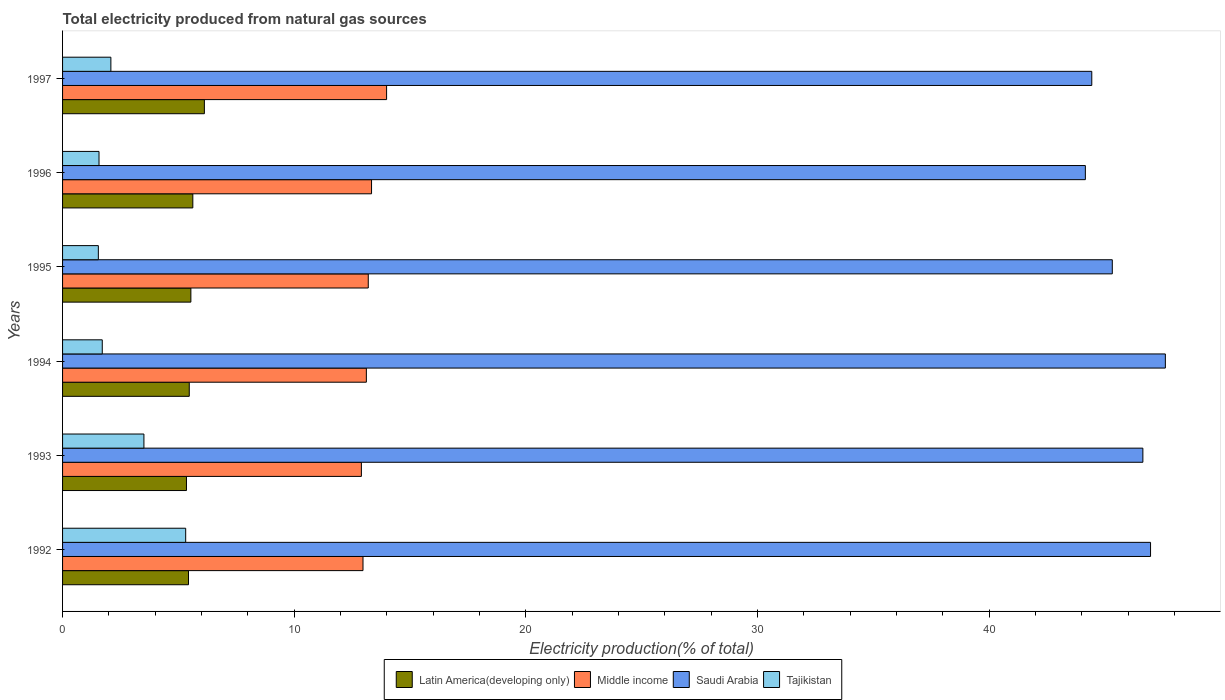How many different coloured bars are there?
Offer a terse response. 4. Are the number of bars per tick equal to the number of legend labels?
Offer a terse response. Yes. How many bars are there on the 3rd tick from the top?
Offer a terse response. 4. How many bars are there on the 1st tick from the bottom?
Offer a very short reply. 4. What is the label of the 6th group of bars from the top?
Provide a succinct answer. 1992. In how many cases, is the number of bars for a given year not equal to the number of legend labels?
Keep it short and to the point. 0. What is the total electricity produced in Middle income in 1993?
Your answer should be very brief. 12.9. Across all years, what is the maximum total electricity produced in Saudi Arabia?
Your answer should be very brief. 47.6. Across all years, what is the minimum total electricity produced in Tajikistan?
Your answer should be very brief. 1.54. In which year was the total electricity produced in Tajikistan maximum?
Provide a succinct answer. 1992. What is the total total electricity produced in Middle income in the graph?
Make the answer very short. 79.5. What is the difference between the total electricity produced in Middle income in 1993 and that in 1997?
Your answer should be very brief. -1.09. What is the difference between the total electricity produced in Middle income in 1996 and the total electricity produced in Saudi Arabia in 1997?
Your answer should be very brief. -31.09. What is the average total electricity produced in Saudi Arabia per year?
Ensure brevity in your answer.  45.85. In the year 1996, what is the difference between the total electricity produced in Tajikistan and total electricity produced in Middle income?
Provide a succinct answer. -11.76. What is the ratio of the total electricity produced in Middle income in 1994 to that in 1996?
Offer a very short reply. 0.98. Is the total electricity produced in Tajikistan in 1992 less than that in 1996?
Give a very brief answer. No. What is the difference between the highest and the second highest total electricity produced in Saudi Arabia?
Your answer should be very brief. 0.64. What is the difference between the highest and the lowest total electricity produced in Saudi Arabia?
Your answer should be compact. 3.45. Is it the case that in every year, the sum of the total electricity produced in Latin America(developing only) and total electricity produced in Tajikistan is greater than the sum of total electricity produced in Saudi Arabia and total electricity produced in Middle income?
Provide a short and direct response. No. What does the 1st bar from the top in 1994 represents?
Make the answer very short. Tajikistan. How many bars are there?
Provide a short and direct response. 24. How many years are there in the graph?
Your response must be concise. 6. Are the values on the major ticks of X-axis written in scientific E-notation?
Ensure brevity in your answer.  No. Does the graph contain any zero values?
Offer a terse response. No. Where does the legend appear in the graph?
Ensure brevity in your answer.  Bottom center. How many legend labels are there?
Make the answer very short. 4. What is the title of the graph?
Ensure brevity in your answer.  Total electricity produced from natural gas sources. What is the label or title of the X-axis?
Provide a succinct answer. Electricity production(% of total). What is the label or title of the Y-axis?
Give a very brief answer. Years. What is the Electricity production(% of total) in Latin America(developing only) in 1992?
Keep it short and to the point. 5.44. What is the Electricity production(% of total) in Middle income in 1992?
Your answer should be very brief. 12.97. What is the Electricity production(% of total) in Saudi Arabia in 1992?
Provide a succinct answer. 46.96. What is the Electricity production(% of total) in Tajikistan in 1992?
Offer a terse response. 5.31. What is the Electricity production(% of total) in Latin America(developing only) in 1993?
Your answer should be very brief. 5.35. What is the Electricity production(% of total) of Middle income in 1993?
Keep it short and to the point. 12.9. What is the Electricity production(% of total) of Saudi Arabia in 1993?
Give a very brief answer. 46.63. What is the Electricity production(% of total) of Tajikistan in 1993?
Your response must be concise. 3.51. What is the Electricity production(% of total) in Latin America(developing only) in 1994?
Your answer should be very brief. 5.47. What is the Electricity production(% of total) in Middle income in 1994?
Offer a terse response. 13.11. What is the Electricity production(% of total) of Saudi Arabia in 1994?
Keep it short and to the point. 47.6. What is the Electricity production(% of total) of Tajikistan in 1994?
Your response must be concise. 1.71. What is the Electricity production(% of total) in Latin America(developing only) in 1995?
Give a very brief answer. 5.54. What is the Electricity production(% of total) of Middle income in 1995?
Your answer should be very brief. 13.2. What is the Electricity production(% of total) of Saudi Arabia in 1995?
Keep it short and to the point. 45.31. What is the Electricity production(% of total) of Tajikistan in 1995?
Offer a very short reply. 1.54. What is the Electricity production(% of total) in Latin America(developing only) in 1996?
Keep it short and to the point. 5.62. What is the Electricity production(% of total) in Middle income in 1996?
Provide a short and direct response. 13.34. What is the Electricity production(% of total) of Saudi Arabia in 1996?
Provide a succinct answer. 44.15. What is the Electricity production(% of total) of Tajikistan in 1996?
Offer a very short reply. 1.57. What is the Electricity production(% of total) in Latin America(developing only) in 1997?
Your response must be concise. 6.12. What is the Electricity production(% of total) in Middle income in 1997?
Offer a terse response. 13.99. What is the Electricity production(% of total) in Saudi Arabia in 1997?
Keep it short and to the point. 44.43. What is the Electricity production(% of total) in Tajikistan in 1997?
Your response must be concise. 2.08. Across all years, what is the maximum Electricity production(% of total) of Latin America(developing only)?
Offer a terse response. 6.12. Across all years, what is the maximum Electricity production(% of total) of Middle income?
Provide a succinct answer. 13.99. Across all years, what is the maximum Electricity production(% of total) of Saudi Arabia?
Your response must be concise. 47.6. Across all years, what is the maximum Electricity production(% of total) in Tajikistan?
Provide a short and direct response. 5.31. Across all years, what is the minimum Electricity production(% of total) of Latin America(developing only)?
Provide a short and direct response. 5.35. Across all years, what is the minimum Electricity production(% of total) of Middle income?
Keep it short and to the point. 12.9. Across all years, what is the minimum Electricity production(% of total) of Saudi Arabia?
Give a very brief answer. 44.15. Across all years, what is the minimum Electricity production(% of total) of Tajikistan?
Make the answer very short. 1.54. What is the total Electricity production(% of total) in Latin America(developing only) in the graph?
Your answer should be very brief. 33.54. What is the total Electricity production(% of total) of Middle income in the graph?
Offer a terse response. 79.5. What is the total Electricity production(% of total) of Saudi Arabia in the graph?
Provide a short and direct response. 275.09. What is the total Electricity production(% of total) in Tajikistan in the graph?
Your response must be concise. 15.74. What is the difference between the Electricity production(% of total) of Latin America(developing only) in 1992 and that in 1993?
Ensure brevity in your answer.  0.09. What is the difference between the Electricity production(% of total) in Middle income in 1992 and that in 1993?
Make the answer very short. 0.07. What is the difference between the Electricity production(% of total) of Saudi Arabia in 1992 and that in 1993?
Your answer should be compact. 0.33. What is the difference between the Electricity production(% of total) in Tajikistan in 1992 and that in 1993?
Keep it short and to the point. 1.8. What is the difference between the Electricity production(% of total) in Latin America(developing only) in 1992 and that in 1994?
Provide a short and direct response. -0.03. What is the difference between the Electricity production(% of total) of Middle income in 1992 and that in 1994?
Offer a terse response. -0.14. What is the difference between the Electricity production(% of total) in Saudi Arabia in 1992 and that in 1994?
Ensure brevity in your answer.  -0.64. What is the difference between the Electricity production(% of total) of Tajikistan in 1992 and that in 1994?
Provide a short and direct response. 3.6. What is the difference between the Electricity production(% of total) of Latin America(developing only) in 1992 and that in 1995?
Offer a terse response. -0.1. What is the difference between the Electricity production(% of total) in Middle income in 1992 and that in 1995?
Your answer should be very brief. -0.23. What is the difference between the Electricity production(% of total) in Saudi Arabia in 1992 and that in 1995?
Provide a short and direct response. 1.65. What is the difference between the Electricity production(% of total) in Tajikistan in 1992 and that in 1995?
Make the answer very short. 3.77. What is the difference between the Electricity production(% of total) of Latin America(developing only) in 1992 and that in 1996?
Offer a very short reply. -0.19. What is the difference between the Electricity production(% of total) in Middle income in 1992 and that in 1996?
Provide a short and direct response. -0.37. What is the difference between the Electricity production(% of total) of Saudi Arabia in 1992 and that in 1996?
Keep it short and to the point. 2.81. What is the difference between the Electricity production(% of total) of Tajikistan in 1992 and that in 1996?
Your answer should be very brief. 3.74. What is the difference between the Electricity production(% of total) of Latin America(developing only) in 1992 and that in 1997?
Your answer should be very brief. -0.69. What is the difference between the Electricity production(% of total) in Middle income in 1992 and that in 1997?
Provide a succinct answer. -1.02. What is the difference between the Electricity production(% of total) in Saudi Arabia in 1992 and that in 1997?
Give a very brief answer. 2.54. What is the difference between the Electricity production(% of total) in Tajikistan in 1992 and that in 1997?
Ensure brevity in your answer.  3.23. What is the difference between the Electricity production(% of total) of Latin America(developing only) in 1993 and that in 1994?
Keep it short and to the point. -0.12. What is the difference between the Electricity production(% of total) in Middle income in 1993 and that in 1994?
Keep it short and to the point. -0.21. What is the difference between the Electricity production(% of total) of Saudi Arabia in 1993 and that in 1994?
Provide a succinct answer. -0.97. What is the difference between the Electricity production(% of total) of Tajikistan in 1993 and that in 1994?
Make the answer very short. 1.8. What is the difference between the Electricity production(% of total) of Latin America(developing only) in 1993 and that in 1995?
Offer a very short reply. -0.19. What is the difference between the Electricity production(% of total) of Middle income in 1993 and that in 1995?
Your response must be concise. -0.3. What is the difference between the Electricity production(% of total) of Saudi Arabia in 1993 and that in 1995?
Keep it short and to the point. 1.32. What is the difference between the Electricity production(% of total) of Tajikistan in 1993 and that in 1995?
Provide a succinct answer. 1.97. What is the difference between the Electricity production(% of total) in Latin America(developing only) in 1993 and that in 1996?
Give a very brief answer. -0.27. What is the difference between the Electricity production(% of total) of Middle income in 1993 and that in 1996?
Make the answer very short. -0.44. What is the difference between the Electricity production(% of total) in Saudi Arabia in 1993 and that in 1996?
Make the answer very short. 2.48. What is the difference between the Electricity production(% of total) of Tajikistan in 1993 and that in 1996?
Your answer should be very brief. 1.94. What is the difference between the Electricity production(% of total) in Latin America(developing only) in 1993 and that in 1997?
Your answer should be very brief. -0.77. What is the difference between the Electricity production(% of total) of Middle income in 1993 and that in 1997?
Offer a terse response. -1.09. What is the difference between the Electricity production(% of total) in Saudi Arabia in 1993 and that in 1997?
Your answer should be very brief. 2.21. What is the difference between the Electricity production(% of total) in Tajikistan in 1993 and that in 1997?
Offer a terse response. 1.43. What is the difference between the Electricity production(% of total) of Latin America(developing only) in 1994 and that in 1995?
Provide a succinct answer. -0.07. What is the difference between the Electricity production(% of total) of Middle income in 1994 and that in 1995?
Your answer should be compact. -0.08. What is the difference between the Electricity production(% of total) of Saudi Arabia in 1994 and that in 1995?
Offer a very short reply. 2.29. What is the difference between the Electricity production(% of total) in Tajikistan in 1994 and that in 1995?
Keep it short and to the point. 0.17. What is the difference between the Electricity production(% of total) in Latin America(developing only) in 1994 and that in 1996?
Offer a very short reply. -0.15. What is the difference between the Electricity production(% of total) of Middle income in 1994 and that in 1996?
Make the answer very short. -0.22. What is the difference between the Electricity production(% of total) of Saudi Arabia in 1994 and that in 1996?
Provide a short and direct response. 3.45. What is the difference between the Electricity production(% of total) of Tajikistan in 1994 and that in 1996?
Provide a succinct answer. 0.14. What is the difference between the Electricity production(% of total) of Latin America(developing only) in 1994 and that in 1997?
Provide a short and direct response. -0.65. What is the difference between the Electricity production(% of total) of Middle income in 1994 and that in 1997?
Ensure brevity in your answer.  -0.87. What is the difference between the Electricity production(% of total) of Saudi Arabia in 1994 and that in 1997?
Your answer should be compact. 3.18. What is the difference between the Electricity production(% of total) in Tajikistan in 1994 and that in 1997?
Provide a succinct answer. -0.37. What is the difference between the Electricity production(% of total) in Latin America(developing only) in 1995 and that in 1996?
Keep it short and to the point. -0.08. What is the difference between the Electricity production(% of total) in Middle income in 1995 and that in 1996?
Provide a short and direct response. -0.14. What is the difference between the Electricity production(% of total) in Saudi Arabia in 1995 and that in 1996?
Ensure brevity in your answer.  1.16. What is the difference between the Electricity production(% of total) of Tajikistan in 1995 and that in 1996?
Your answer should be compact. -0.03. What is the difference between the Electricity production(% of total) in Latin America(developing only) in 1995 and that in 1997?
Give a very brief answer. -0.58. What is the difference between the Electricity production(% of total) in Middle income in 1995 and that in 1997?
Give a very brief answer. -0.79. What is the difference between the Electricity production(% of total) in Saudi Arabia in 1995 and that in 1997?
Give a very brief answer. 0.89. What is the difference between the Electricity production(% of total) of Tajikistan in 1995 and that in 1997?
Offer a terse response. -0.54. What is the difference between the Electricity production(% of total) in Latin America(developing only) in 1996 and that in 1997?
Your answer should be compact. -0.5. What is the difference between the Electricity production(% of total) of Middle income in 1996 and that in 1997?
Your answer should be compact. -0.65. What is the difference between the Electricity production(% of total) of Saudi Arabia in 1996 and that in 1997?
Keep it short and to the point. -0.28. What is the difference between the Electricity production(% of total) of Tajikistan in 1996 and that in 1997?
Offer a terse response. -0.51. What is the difference between the Electricity production(% of total) in Latin America(developing only) in 1992 and the Electricity production(% of total) in Middle income in 1993?
Offer a very short reply. -7.46. What is the difference between the Electricity production(% of total) in Latin America(developing only) in 1992 and the Electricity production(% of total) in Saudi Arabia in 1993?
Offer a very short reply. -41.2. What is the difference between the Electricity production(% of total) in Latin America(developing only) in 1992 and the Electricity production(% of total) in Tajikistan in 1993?
Your answer should be very brief. 1.92. What is the difference between the Electricity production(% of total) in Middle income in 1992 and the Electricity production(% of total) in Saudi Arabia in 1993?
Your response must be concise. -33.66. What is the difference between the Electricity production(% of total) of Middle income in 1992 and the Electricity production(% of total) of Tajikistan in 1993?
Make the answer very short. 9.46. What is the difference between the Electricity production(% of total) of Saudi Arabia in 1992 and the Electricity production(% of total) of Tajikistan in 1993?
Your answer should be very brief. 43.45. What is the difference between the Electricity production(% of total) in Latin America(developing only) in 1992 and the Electricity production(% of total) in Middle income in 1994?
Offer a terse response. -7.68. What is the difference between the Electricity production(% of total) of Latin America(developing only) in 1992 and the Electricity production(% of total) of Saudi Arabia in 1994?
Ensure brevity in your answer.  -42.17. What is the difference between the Electricity production(% of total) in Latin America(developing only) in 1992 and the Electricity production(% of total) in Tajikistan in 1994?
Your response must be concise. 3.72. What is the difference between the Electricity production(% of total) of Middle income in 1992 and the Electricity production(% of total) of Saudi Arabia in 1994?
Offer a very short reply. -34.63. What is the difference between the Electricity production(% of total) in Middle income in 1992 and the Electricity production(% of total) in Tajikistan in 1994?
Provide a short and direct response. 11.25. What is the difference between the Electricity production(% of total) in Saudi Arabia in 1992 and the Electricity production(% of total) in Tajikistan in 1994?
Keep it short and to the point. 45.25. What is the difference between the Electricity production(% of total) in Latin America(developing only) in 1992 and the Electricity production(% of total) in Middle income in 1995?
Ensure brevity in your answer.  -7.76. What is the difference between the Electricity production(% of total) in Latin America(developing only) in 1992 and the Electricity production(% of total) in Saudi Arabia in 1995?
Make the answer very short. -39.88. What is the difference between the Electricity production(% of total) in Latin America(developing only) in 1992 and the Electricity production(% of total) in Tajikistan in 1995?
Give a very brief answer. 3.89. What is the difference between the Electricity production(% of total) of Middle income in 1992 and the Electricity production(% of total) of Saudi Arabia in 1995?
Give a very brief answer. -32.34. What is the difference between the Electricity production(% of total) of Middle income in 1992 and the Electricity production(% of total) of Tajikistan in 1995?
Your answer should be very brief. 11.42. What is the difference between the Electricity production(% of total) of Saudi Arabia in 1992 and the Electricity production(% of total) of Tajikistan in 1995?
Provide a succinct answer. 45.42. What is the difference between the Electricity production(% of total) in Latin America(developing only) in 1992 and the Electricity production(% of total) in Middle income in 1996?
Provide a short and direct response. -7.9. What is the difference between the Electricity production(% of total) of Latin America(developing only) in 1992 and the Electricity production(% of total) of Saudi Arabia in 1996?
Provide a short and direct response. -38.71. What is the difference between the Electricity production(% of total) of Latin America(developing only) in 1992 and the Electricity production(% of total) of Tajikistan in 1996?
Offer a terse response. 3.86. What is the difference between the Electricity production(% of total) in Middle income in 1992 and the Electricity production(% of total) in Saudi Arabia in 1996?
Your answer should be compact. -31.18. What is the difference between the Electricity production(% of total) of Middle income in 1992 and the Electricity production(% of total) of Tajikistan in 1996?
Provide a succinct answer. 11.39. What is the difference between the Electricity production(% of total) in Saudi Arabia in 1992 and the Electricity production(% of total) in Tajikistan in 1996?
Provide a succinct answer. 45.39. What is the difference between the Electricity production(% of total) of Latin America(developing only) in 1992 and the Electricity production(% of total) of Middle income in 1997?
Keep it short and to the point. -8.55. What is the difference between the Electricity production(% of total) of Latin America(developing only) in 1992 and the Electricity production(% of total) of Saudi Arabia in 1997?
Provide a succinct answer. -38.99. What is the difference between the Electricity production(% of total) in Latin America(developing only) in 1992 and the Electricity production(% of total) in Tajikistan in 1997?
Your response must be concise. 3.35. What is the difference between the Electricity production(% of total) of Middle income in 1992 and the Electricity production(% of total) of Saudi Arabia in 1997?
Offer a very short reply. -31.46. What is the difference between the Electricity production(% of total) in Middle income in 1992 and the Electricity production(% of total) in Tajikistan in 1997?
Offer a terse response. 10.88. What is the difference between the Electricity production(% of total) of Saudi Arabia in 1992 and the Electricity production(% of total) of Tajikistan in 1997?
Provide a succinct answer. 44.88. What is the difference between the Electricity production(% of total) of Latin America(developing only) in 1993 and the Electricity production(% of total) of Middle income in 1994?
Ensure brevity in your answer.  -7.77. What is the difference between the Electricity production(% of total) of Latin America(developing only) in 1993 and the Electricity production(% of total) of Saudi Arabia in 1994?
Offer a terse response. -42.25. What is the difference between the Electricity production(% of total) of Latin America(developing only) in 1993 and the Electricity production(% of total) of Tajikistan in 1994?
Offer a terse response. 3.63. What is the difference between the Electricity production(% of total) in Middle income in 1993 and the Electricity production(% of total) in Saudi Arabia in 1994?
Your response must be concise. -34.7. What is the difference between the Electricity production(% of total) in Middle income in 1993 and the Electricity production(% of total) in Tajikistan in 1994?
Keep it short and to the point. 11.19. What is the difference between the Electricity production(% of total) of Saudi Arabia in 1993 and the Electricity production(% of total) of Tajikistan in 1994?
Your answer should be very brief. 44.92. What is the difference between the Electricity production(% of total) in Latin America(developing only) in 1993 and the Electricity production(% of total) in Middle income in 1995?
Offer a terse response. -7.85. What is the difference between the Electricity production(% of total) of Latin America(developing only) in 1993 and the Electricity production(% of total) of Saudi Arabia in 1995?
Your answer should be compact. -39.96. What is the difference between the Electricity production(% of total) in Latin America(developing only) in 1993 and the Electricity production(% of total) in Tajikistan in 1995?
Offer a terse response. 3.8. What is the difference between the Electricity production(% of total) in Middle income in 1993 and the Electricity production(% of total) in Saudi Arabia in 1995?
Keep it short and to the point. -32.41. What is the difference between the Electricity production(% of total) in Middle income in 1993 and the Electricity production(% of total) in Tajikistan in 1995?
Your response must be concise. 11.35. What is the difference between the Electricity production(% of total) in Saudi Arabia in 1993 and the Electricity production(% of total) in Tajikistan in 1995?
Keep it short and to the point. 45.09. What is the difference between the Electricity production(% of total) in Latin America(developing only) in 1993 and the Electricity production(% of total) in Middle income in 1996?
Offer a very short reply. -7.99. What is the difference between the Electricity production(% of total) of Latin America(developing only) in 1993 and the Electricity production(% of total) of Saudi Arabia in 1996?
Your answer should be compact. -38.8. What is the difference between the Electricity production(% of total) of Latin America(developing only) in 1993 and the Electricity production(% of total) of Tajikistan in 1996?
Offer a very short reply. 3.77. What is the difference between the Electricity production(% of total) in Middle income in 1993 and the Electricity production(% of total) in Saudi Arabia in 1996?
Provide a short and direct response. -31.25. What is the difference between the Electricity production(% of total) in Middle income in 1993 and the Electricity production(% of total) in Tajikistan in 1996?
Give a very brief answer. 11.33. What is the difference between the Electricity production(% of total) in Saudi Arabia in 1993 and the Electricity production(% of total) in Tajikistan in 1996?
Your response must be concise. 45.06. What is the difference between the Electricity production(% of total) in Latin America(developing only) in 1993 and the Electricity production(% of total) in Middle income in 1997?
Make the answer very short. -8.64. What is the difference between the Electricity production(% of total) of Latin America(developing only) in 1993 and the Electricity production(% of total) of Saudi Arabia in 1997?
Ensure brevity in your answer.  -39.08. What is the difference between the Electricity production(% of total) in Latin America(developing only) in 1993 and the Electricity production(% of total) in Tajikistan in 1997?
Your answer should be very brief. 3.26. What is the difference between the Electricity production(% of total) in Middle income in 1993 and the Electricity production(% of total) in Saudi Arabia in 1997?
Offer a very short reply. -31.53. What is the difference between the Electricity production(% of total) of Middle income in 1993 and the Electricity production(% of total) of Tajikistan in 1997?
Your response must be concise. 10.81. What is the difference between the Electricity production(% of total) in Saudi Arabia in 1993 and the Electricity production(% of total) in Tajikistan in 1997?
Ensure brevity in your answer.  44.55. What is the difference between the Electricity production(% of total) in Latin America(developing only) in 1994 and the Electricity production(% of total) in Middle income in 1995?
Your answer should be compact. -7.73. What is the difference between the Electricity production(% of total) in Latin America(developing only) in 1994 and the Electricity production(% of total) in Saudi Arabia in 1995?
Offer a very short reply. -39.84. What is the difference between the Electricity production(% of total) in Latin America(developing only) in 1994 and the Electricity production(% of total) in Tajikistan in 1995?
Offer a very short reply. 3.92. What is the difference between the Electricity production(% of total) of Middle income in 1994 and the Electricity production(% of total) of Saudi Arabia in 1995?
Offer a terse response. -32.2. What is the difference between the Electricity production(% of total) of Middle income in 1994 and the Electricity production(% of total) of Tajikistan in 1995?
Give a very brief answer. 11.57. What is the difference between the Electricity production(% of total) in Saudi Arabia in 1994 and the Electricity production(% of total) in Tajikistan in 1995?
Offer a terse response. 46.06. What is the difference between the Electricity production(% of total) of Latin America(developing only) in 1994 and the Electricity production(% of total) of Middle income in 1996?
Offer a terse response. -7.87. What is the difference between the Electricity production(% of total) of Latin America(developing only) in 1994 and the Electricity production(% of total) of Saudi Arabia in 1996?
Your response must be concise. -38.68. What is the difference between the Electricity production(% of total) in Latin America(developing only) in 1994 and the Electricity production(% of total) in Tajikistan in 1996?
Your answer should be very brief. 3.9. What is the difference between the Electricity production(% of total) in Middle income in 1994 and the Electricity production(% of total) in Saudi Arabia in 1996?
Your answer should be compact. -31.04. What is the difference between the Electricity production(% of total) in Middle income in 1994 and the Electricity production(% of total) in Tajikistan in 1996?
Keep it short and to the point. 11.54. What is the difference between the Electricity production(% of total) of Saudi Arabia in 1994 and the Electricity production(% of total) of Tajikistan in 1996?
Your answer should be very brief. 46.03. What is the difference between the Electricity production(% of total) in Latin America(developing only) in 1994 and the Electricity production(% of total) in Middle income in 1997?
Keep it short and to the point. -8.52. What is the difference between the Electricity production(% of total) of Latin America(developing only) in 1994 and the Electricity production(% of total) of Saudi Arabia in 1997?
Make the answer very short. -38.96. What is the difference between the Electricity production(% of total) in Latin America(developing only) in 1994 and the Electricity production(% of total) in Tajikistan in 1997?
Make the answer very short. 3.38. What is the difference between the Electricity production(% of total) in Middle income in 1994 and the Electricity production(% of total) in Saudi Arabia in 1997?
Give a very brief answer. -31.31. What is the difference between the Electricity production(% of total) of Middle income in 1994 and the Electricity production(% of total) of Tajikistan in 1997?
Give a very brief answer. 11.03. What is the difference between the Electricity production(% of total) of Saudi Arabia in 1994 and the Electricity production(% of total) of Tajikistan in 1997?
Make the answer very short. 45.52. What is the difference between the Electricity production(% of total) in Latin America(developing only) in 1995 and the Electricity production(% of total) in Middle income in 1996?
Offer a terse response. -7.8. What is the difference between the Electricity production(% of total) in Latin America(developing only) in 1995 and the Electricity production(% of total) in Saudi Arabia in 1996?
Your answer should be compact. -38.61. What is the difference between the Electricity production(% of total) in Latin America(developing only) in 1995 and the Electricity production(% of total) in Tajikistan in 1996?
Offer a terse response. 3.96. What is the difference between the Electricity production(% of total) in Middle income in 1995 and the Electricity production(% of total) in Saudi Arabia in 1996?
Ensure brevity in your answer.  -30.95. What is the difference between the Electricity production(% of total) in Middle income in 1995 and the Electricity production(% of total) in Tajikistan in 1996?
Provide a succinct answer. 11.62. What is the difference between the Electricity production(% of total) in Saudi Arabia in 1995 and the Electricity production(% of total) in Tajikistan in 1996?
Give a very brief answer. 43.74. What is the difference between the Electricity production(% of total) in Latin America(developing only) in 1995 and the Electricity production(% of total) in Middle income in 1997?
Your answer should be very brief. -8.45. What is the difference between the Electricity production(% of total) in Latin America(developing only) in 1995 and the Electricity production(% of total) in Saudi Arabia in 1997?
Your response must be concise. -38.89. What is the difference between the Electricity production(% of total) of Latin America(developing only) in 1995 and the Electricity production(% of total) of Tajikistan in 1997?
Make the answer very short. 3.45. What is the difference between the Electricity production(% of total) of Middle income in 1995 and the Electricity production(% of total) of Saudi Arabia in 1997?
Your answer should be compact. -31.23. What is the difference between the Electricity production(% of total) of Middle income in 1995 and the Electricity production(% of total) of Tajikistan in 1997?
Give a very brief answer. 11.11. What is the difference between the Electricity production(% of total) in Saudi Arabia in 1995 and the Electricity production(% of total) in Tajikistan in 1997?
Offer a terse response. 43.23. What is the difference between the Electricity production(% of total) of Latin America(developing only) in 1996 and the Electricity production(% of total) of Middle income in 1997?
Provide a short and direct response. -8.36. What is the difference between the Electricity production(% of total) in Latin America(developing only) in 1996 and the Electricity production(% of total) in Saudi Arabia in 1997?
Your response must be concise. -38.8. What is the difference between the Electricity production(% of total) in Latin America(developing only) in 1996 and the Electricity production(% of total) in Tajikistan in 1997?
Make the answer very short. 3.54. What is the difference between the Electricity production(% of total) in Middle income in 1996 and the Electricity production(% of total) in Saudi Arabia in 1997?
Make the answer very short. -31.09. What is the difference between the Electricity production(% of total) of Middle income in 1996 and the Electricity production(% of total) of Tajikistan in 1997?
Give a very brief answer. 11.25. What is the difference between the Electricity production(% of total) in Saudi Arabia in 1996 and the Electricity production(% of total) in Tajikistan in 1997?
Your answer should be compact. 42.06. What is the average Electricity production(% of total) in Latin America(developing only) per year?
Provide a short and direct response. 5.59. What is the average Electricity production(% of total) of Middle income per year?
Your answer should be compact. 13.25. What is the average Electricity production(% of total) in Saudi Arabia per year?
Give a very brief answer. 45.85. What is the average Electricity production(% of total) of Tajikistan per year?
Your answer should be compact. 2.62. In the year 1992, what is the difference between the Electricity production(% of total) of Latin America(developing only) and Electricity production(% of total) of Middle income?
Offer a terse response. -7.53. In the year 1992, what is the difference between the Electricity production(% of total) of Latin America(developing only) and Electricity production(% of total) of Saudi Arabia?
Ensure brevity in your answer.  -41.53. In the year 1992, what is the difference between the Electricity production(% of total) in Latin America(developing only) and Electricity production(% of total) in Tajikistan?
Make the answer very short. 0.12. In the year 1992, what is the difference between the Electricity production(% of total) in Middle income and Electricity production(% of total) in Saudi Arabia?
Keep it short and to the point. -33.99. In the year 1992, what is the difference between the Electricity production(% of total) in Middle income and Electricity production(% of total) in Tajikistan?
Your answer should be very brief. 7.65. In the year 1992, what is the difference between the Electricity production(% of total) of Saudi Arabia and Electricity production(% of total) of Tajikistan?
Provide a succinct answer. 41.65. In the year 1993, what is the difference between the Electricity production(% of total) of Latin America(developing only) and Electricity production(% of total) of Middle income?
Keep it short and to the point. -7.55. In the year 1993, what is the difference between the Electricity production(% of total) of Latin America(developing only) and Electricity production(% of total) of Saudi Arabia?
Offer a very short reply. -41.28. In the year 1993, what is the difference between the Electricity production(% of total) in Latin America(developing only) and Electricity production(% of total) in Tajikistan?
Provide a short and direct response. 1.84. In the year 1993, what is the difference between the Electricity production(% of total) in Middle income and Electricity production(% of total) in Saudi Arabia?
Keep it short and to the point. -33.73. In the year 1993, what is the difference between the Electricity production(% of total) of Middle income and Electricity production(% of total) of Tajikistan?
Your answer should be compact. 9.39. In the year 1993, what is the difference between the Electricity production(% of total) of Saudi Arabia and Electricity production(% of total) of Tajikistan?
Your answer should be very brief. 43.12. In the year 1994, what is the difference between the Electricity production(% of total) in Latin America(developing only) and Electricity production(% of total) in Middle income?
Provide a succinct answer. -7.64. In the year 1994, what is the difference between the Electricity production(% of total) of Latin America(developing only) and Electricity production(% of total) of Saudi Arabia?
Provide a succinct answer. -42.13. In the year 1994, what is the difference between the Electricity production(% of total) in Latin America(developing only) and Electricity production(% of total) in Tajikistan?
Make the answer very short. 3.76. In the year 1994, what is the difference between the Electricity production(% of total) in Middle income and Electricity production(% of total) in Saudi Arabia?
Your answer should be compact. -34.49. In the year 1994, what is the difference between the Electricity production(% of total) of Middle income and Electricity production(% of total) of Tajikistan?
Ensure brevity in your answer.  11.4. In the year 1994, what is the difference between the Electricity production(% of total) of Saudi Arabia and Electricity production(% of total) of Tajikistan?
Make the answer very short. 45.89. In the year 1995, what is the difference between the Electricity production(% of total) of Latin America(developing only) and Electricity production(% of total) of Middle income?
Your response must be concise. -7.66. In the year 1995, what is the difference between the Electricity production(% of total) in Latin America(developing only) and Electricity production(% of total) in Saudi Arabia?
Ensure brevity in your answer.  -39.77. In the year 1995, what is the difference between the Electricity production(% of total) in Latin America(developing only) and Electricity production(% of total) in Tajikistan?
Ensure brevity in your answer.  3.99. In the year 1995, what is the difference between the Electricity production(% of total) in Middle income and Electricity production(% of total) in Saudi Arabia?
Provide a succinct answer. -32.12. In the year 1995, what is the difference between the Electricity production(% of total) of Middle income and Electricity production(% of total) of Tajikistan?
Keep it short and to the point. 11.65. In the year 1995, what is the difference between the Electricity production(% of total) of Saudi Arabia and Electricity production(% of total) of Tajikistan?
Your answer should be very brief. 43.77. In the year 1996, what is the difference between the Electricity production(% of total) of Latin America(developing only) and Electricity production(% of total) of Middle income?
Provide a short and direct response. -7.71. In the year 1996, what is the difference between the Electricity production(% of total) in Latin America(developing only) and Electricity production(% of total) in Saudi Arabia?
Ensure brevity in your answer.  -38.53. In the year 1996, what is the difference between the Electricity production(% of total) of Latin America(developing only) and Electricity production(% of total) of Tajikistan?
Give a very brief answer. 4.05. In the year 1996, what is the difference between the Electricity production(% of total) of Middle income and Electricity production(% of total) of Saudi Arabia?
Give a very brief answer. -30.81. In the year 1996, what is the difference between the Electricity production(% of total) in Middle income and Electricity production(% of total) in Tajikistan?
Your response must be concise. 11.76. In the year 1996, what is the difference between the Electricity production(% of total) in Saudi Arabia and Electricity production(% of total) in Tajikistan?
Make the answer very short. 42.58. In the year 1997, what is the difference between the Electricity production(% of total) in Latin America(developing only) and Electricity production(% of total) in Middle income?
Offer a very short reply. -7.87. In the year 1997, what is the difference between the Electricity production(% of total) of Latin America(developing only) and Electricity production(% of total) of Saudi Arabia?
Keep it short and to the point. -38.31. In the year 1997, what is the difference between the Electricity production(% of total) in Latin America(developing only) and Electricity production(% of total) in Tajikistan?
Your answer should be compact. 4.04. In the year 1997, what is the difference between the Electricity production(% of total) of Middle income and Electricity production(% of total) of Saudi Arabia?
Offer a very short reply. -30.44. In the year 1997, what is the difference between the Electricity production(% of total) in Middle income and Electricity production(% of total) in Tajikistan?
Provide a succinct answer. 11.9. In the year 1997, what is the difference between the Electricity production(% of total) in Saudi Arabia and Electricity production(% of total) in Tajikistan?
Give a very brief answer. 42.34. What is the ratio of the Electricity production(% of total) of Latin America(developing only) in 1992 to that in 1993?
Provide a succinct answer. 1.02. What is the ratio of the Electricity production(% of total) in Middle income in 1992 to that in 1993?
Ensure brevity in your answer.  1.01. What is the ratio of the Electricity production(% of total) of Saudi Arabia in 1992 to that in 1993?
Your answer should be very brief. 1.01. What is the ratio of the Electricity production(% of total) of Tajikistan in 1992 to that in 1993?
Provide a short and direct response. 1.51. What is the ratio of the Electricity production(% of total) in Latin America(developing only) in 1992 to that in 1994?
Make the answer very short. 0.99. What is the ratio of the Electricity production(% of total) of Saudi Arabia in 1992 to that in 1994?
Keep it short and to the point. 0.99. What is the ratio of the Electricity production(% of total) in Tajikistan in 1992 to that in 1994?
Ensure brevity in your answer.  3.1. What is the ratio of the Electricity production(% of total) of Latin America(developing only) in 1992 to that in 1995?
Make the answer very short. 0.98. What is the ratio of the Electricity production(% of total) of Middle income in 1992 to that in 1995?
Keep it short and to the point. 0.98. What is the ratio of the Electricity production(% of total) in Saudi Arabia in 1992 to that in 1995?
Ensure brevity in your answer.  1.04. What is the ratio of the Electricity production(% of total) of Tajikistan in 1992 to that in 1995?
Keep it short and to the point. 3.44. What is the ratio of the Electricity production(% of total) in Latin America(developing only) in 1992 to that in 1996?
Give a very brief answer. 0.97. What is the ratio of the Electricity production(% of total) of Middle income in 1992 to that in 1996?
Offer a terse response. 0.97. What is the ratio of the Electricity production(% of total) of Saudi Arabia in 1992 to that in 1996?
Offer a terse response. 1.06. What is the ratio of the Electricity production(% of total) of Tajikistan in 1992 to that in 1996?
Give a very brief answer. 3.38. What is the ratio of the Electricity production(% of total) of Latin America(developing only) in 1992 to that in 1997?
Give a very brief answer. 0.89. What is the ratio of the Electricity production(% of total) of Middle income in 1992 to that in 1997?
Give a very brief answer. 0.93. What is the ratio of the Electricity production(% of total) in Saudi Arabia in 1992 to that in 1997?
Offer a terse response. 1.06. What is the ratio of the Electricity production(% of total) of Tajikistan in 1992 to that in 1997?
Provide a succinct answer. 2.55. What is the ratio of the Electricity production(% of total) in Latin America(developing only) in 1993 to that in 1994?
Keep it short and to the point. 0.98. What is the ratio of the Electricity production(% of total) in Middle income in 1993 to that in 1994?
Ensure brevity in your answer.  0.98. What is the ratio of the Electricity production(% of total) of Saudi Arabia in 1993 to that in 1994?
Provide a succinct answer. 0.98. What is the ratio of the Electricity production(% of total) of Tajikistan in 1993 to that in 1994?
Your answer should be very brief. 2.05. What is the ratio of the Electricity production(% of total) in Latin America(developing only) in 1993 to that in 1995?
Ensure brevity in your answer.  0.97. What is the ratio of the Electricity production(% of total) of Middle income in 1993 to that in 1995?
Provide a succinct answer. 0.98. What is the ratio of the Electricity production(% of total) of Saudi Arabia in 1993 to that in 1995?
Provide a succinct answer. 1.03. What is the ratio of the Electricity production(% of total) of Tajikistan in 1993 to that in 1995?
Offer a very short reply. 2.27. What is the ratio of the Electricity production(% of total) in Latin America(developing only) in 1993 to that in 1996?
Keep it short and to the point. 0.95. What is the ratio of the Electricity production(% of total) of Middle income in 1993 to that in 1996?
Your answer should be very brief. 0.97. What is the ratio of the Electricity production(% of total) in Saudi Arabia in 1993 to that in 1996?
Provide a short and direct response. 1.06. What is the ratio of the Electricity production(% of total) of Tajikistan in 1993 to that in 1996?
Ensure brevity in your answer.  2.23. What is the ratio of the Electricity production(% of total) of Latin America(developing only) in 1993 to that in 1997?
Make the answer very short. 0.87. What is the ratio of the Electricity production(% of total) in Middle income in 1993 to that in 1997?
Ensure brevity in your answer.  0.92. What is the ratio of the Electricity production(% of total) in Saudi Arabia in 1993 to that in 1997?
Provide a short and direct response. 1.05. What is the ratio of the Electricity production(% of total) of Tajikistan in 1993 to that in 1997?
Offer a terse response. 1.68. What is the ratio of the Electricity production(% of total) of Latin America(developing only) in 1994 to that in 1995?
Your answer should be compact. 0.99. What is the ratio of the Electricity production(% of total) of Middle income in 1994 to that in 1995?
Keep it short and to the point. 0.99. What is the ratio of the Electricity production(% of total) in Saudi Arabia in 1994 to that in 1995?
Keep it short and to the point. 1.05. What is the ratio of the Electricity production(% of total) of Tajikistan in 1994 to that in 1995?
Your answer should be compact. 1.11. What is the ratio of the Electricity production(% of total) in Latin America(developing only) in 1994 to that in 1996?
Keep it short and to the point. 0.97. What is the ratio of the Electricity production(% of total) in Middle income in 1994 to that in 1996?
Offer a terse response. 0.98. What is the ratio of the Electricity production(% of total) in Saudi Arabia in 1994 to that in 1996?
Ensure brevity in your answer.  1.08. What is the ratio of the Electricity production(% of total) in Tajikistan in 1994 to that in 1996?
Provide a short and direct response. 1.09. What is the ratio of the Electricity production(% of total) of Latin America(developing only) in 1994 to that in 1997?
Keep it short and to the point. 0.89. What is the ratio of the Electricity production(% of total) of Middle income in 1994 to that in 1997?
Provide a succinct answer. 0.94. What is the ratio of the Electricity production(% of total) in Saudi Arabia in 1994 to that in 1997?
Give a very brief answer. 1.07. What is the ratio of the Electricity production(% of total) of Tajikistan in 1994 to that in 1997?
Provide a succinct answer. 0.82. What is the ratio of the Electricity production(% of total) of Latin America(developing only) in 1995 to that in 1996?
Keep it short and to the point. 0.98. What is the ratio of the Electricity production(% of total) of Saudi Arabia in 1995 to that in 1996?
Offer a terse response. 1.03. What is the ratio of the Electricity production(% of total) of Tajikistan in 1995 to that in 1996?
Offer a very short reply. 0.98. What is the ratio of the Electricity production(% of total) in Latin America(developing only) in 1995 to that in 1997?
Provide a short and direct response. 0.9. What is the ratio of the Electricity production(% of total) in Middle income in 1995 to that in 1997?
Ensure brevity in your answer.  0.94. What is the ratio of the Electricity production(% of total) of Saudi Arabia in 1995 to that in 1997?
Make the answer very short. 1.02. What is the ratio of the Electricity production(% of total) of Tajikistan in 1995 to that in 1997?
Your response must be concise. 0.74. What is the ratio of the Electricity production(% of total) in Latin America(developing only) in 1996 to that in 1997?
Keep it short and to the point. 0.92. What is the ratio of the Electricity production(% of total) in Middle income in 1996 to that in 1997?
Provide a succinct answer. 0.95. What is the ratio of the Electricity production(% of total) in Saudi Arabia in 1996 to that in 1997?
Offer a very short reply. 0.99. What is the ratio of the Electricity production(% of total) in Tajikistan in 1996 to that in 1997?
Your answer should be very brief. 0.75. What is the difference between the highest and the second highest Electricity production(% of total) of Latin America(developing only)?
Your answer should be very brief. 0.5. What is the difference between the highest and the second highest Electricity production(% of total) of Middle income?
Your answer should be compact. 0.65. What is the difference between the highest and the second highest Electricity production(% of total) in Saudi Arabia?
Ensure brevity in your answer.  0.64. What is the difference between the highest and the second highest Electricity production(% of total) in Tajikistan?
Your answer should be compact. 1.8. What is the difference between the highest and the lowest Electricity production(% of total) in Latin America(developing only)?
Make the answer very short. 0.77. What is the difference between the highest and the lowest Electricity production(% of total) of Middle income?
Give a very brief answer. 1.09. What is the difference between the highest and the lowest Electricity production(% of total) of Saudi Arabia?
Provide a short and direct response. 3.45. What is the difference between the highest and the lowest Electricity production(% of total) in Tajikistan?
Provide a short and direct response. 3.77. 